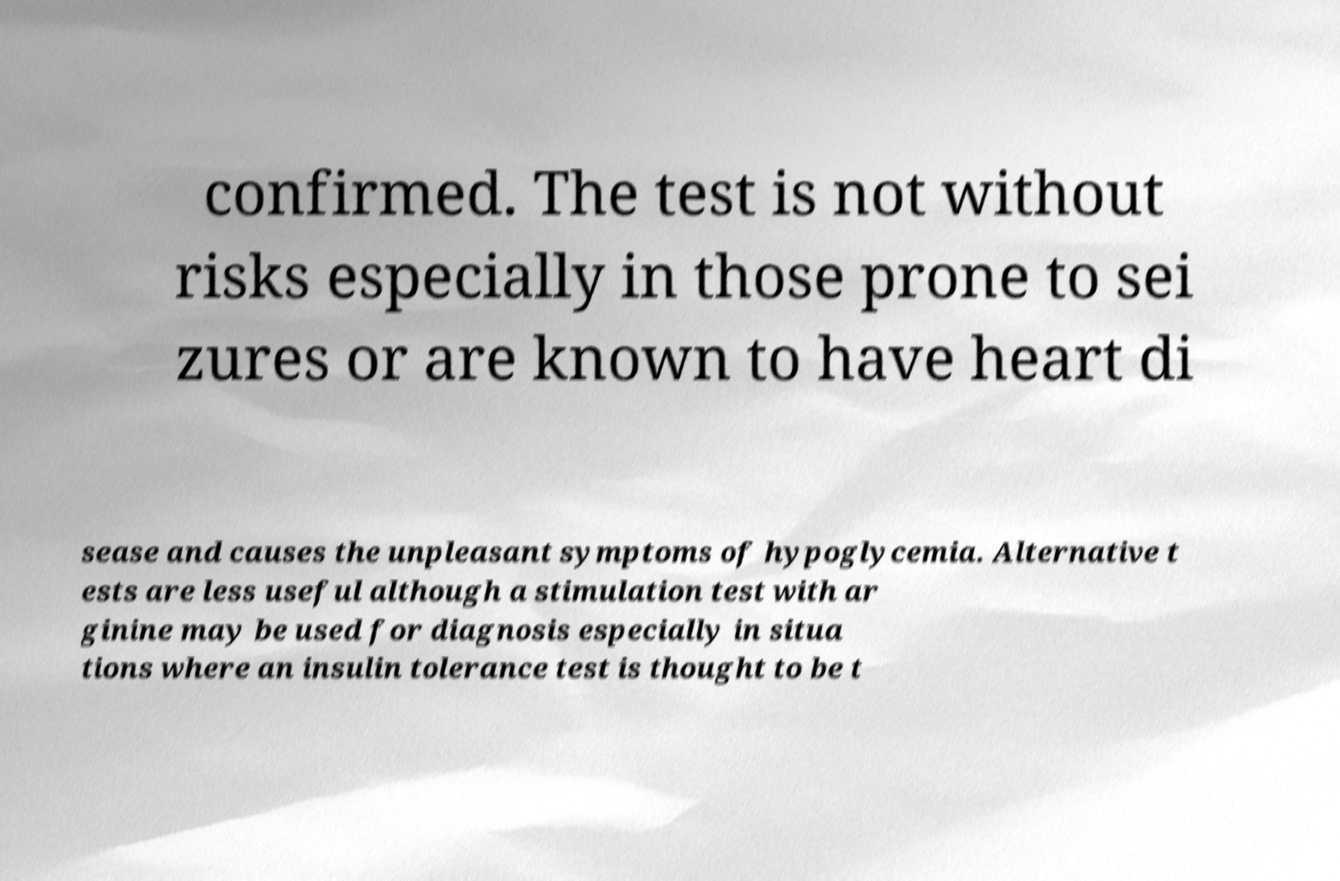I need the written content from this picture converted into text. Can you do that? confirmed. The test is not without risks especially in those prone to sei zures or are known to have heart di sease and causes the unpleasant symptoms of hypoglycemia. Alternative t ests are less useful although a stimulation test with ar ginine may be used for diagnosis especially in situa tions where an insulin tolerance test is thought to be t 